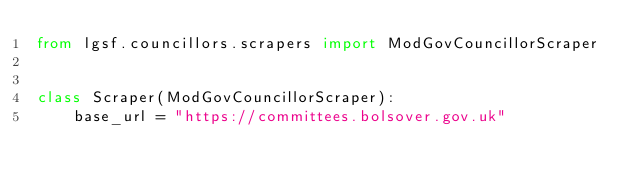<code> <loc_0><loc_0><loc_500><loc_500><_Python_>from lgsf.councillors.scrapers import ModGovCouncillorScraper


class Scraper(ModGovCouncillorScraper):
    base_url = "https://committees.bolsover.gov.uk"
</code> 